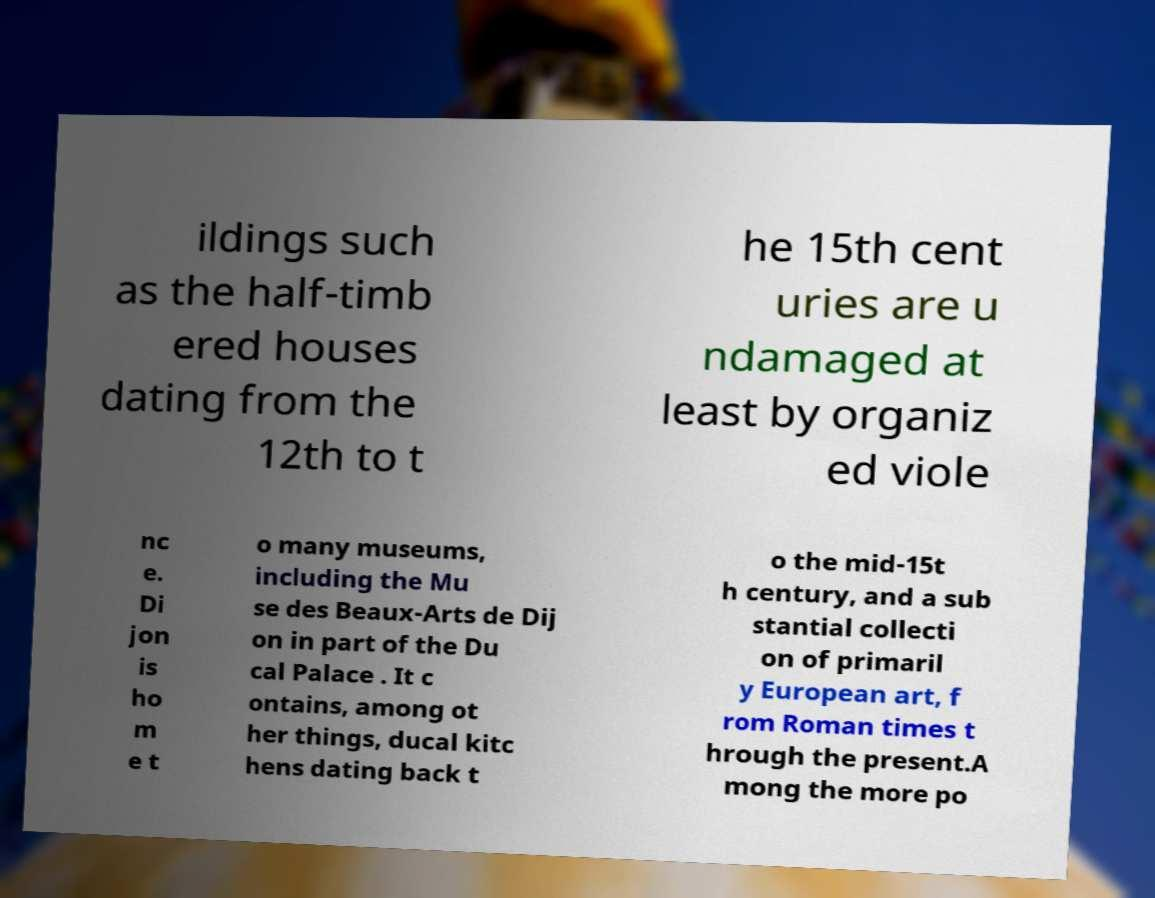For documentation purposes, I need the text within this image transcribed. Could you provide that? ildings such as the half-timb ered houses dating from the 12th to t he 15th cent uries are u ndamaged at least by organiz ed viole nc e. Di jon is ho m e t o many museums, including the Mu se des Beaux-Arts de Dij on in part of the Du cal Palace . It c ontains, among ot her things, ducal kitc hens dating back t o the mid-15t h century, and a sub stantial collecti on of primaril y European art, f rom Roman times t hrough the present.A mong the more po 